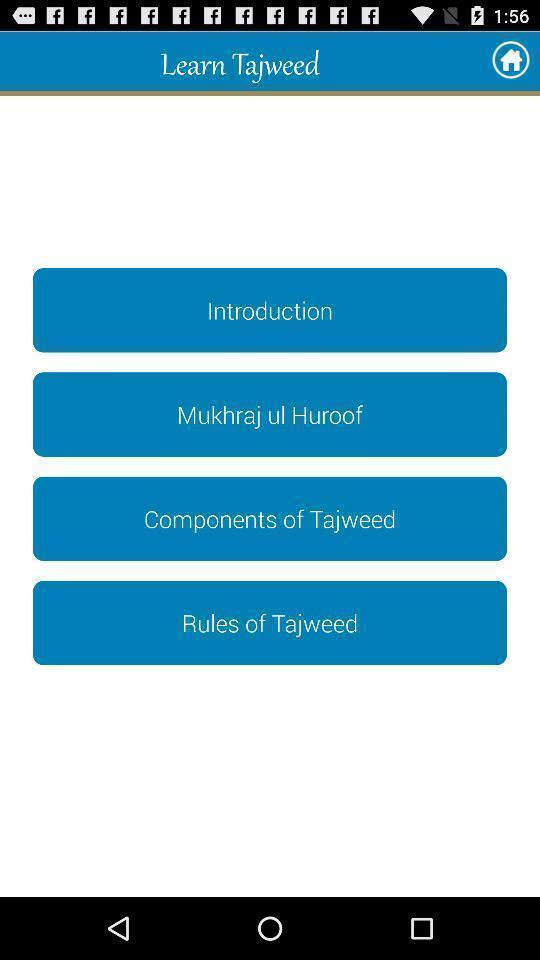What details can you identify in this image? Welcome page with options in a religion related app. 